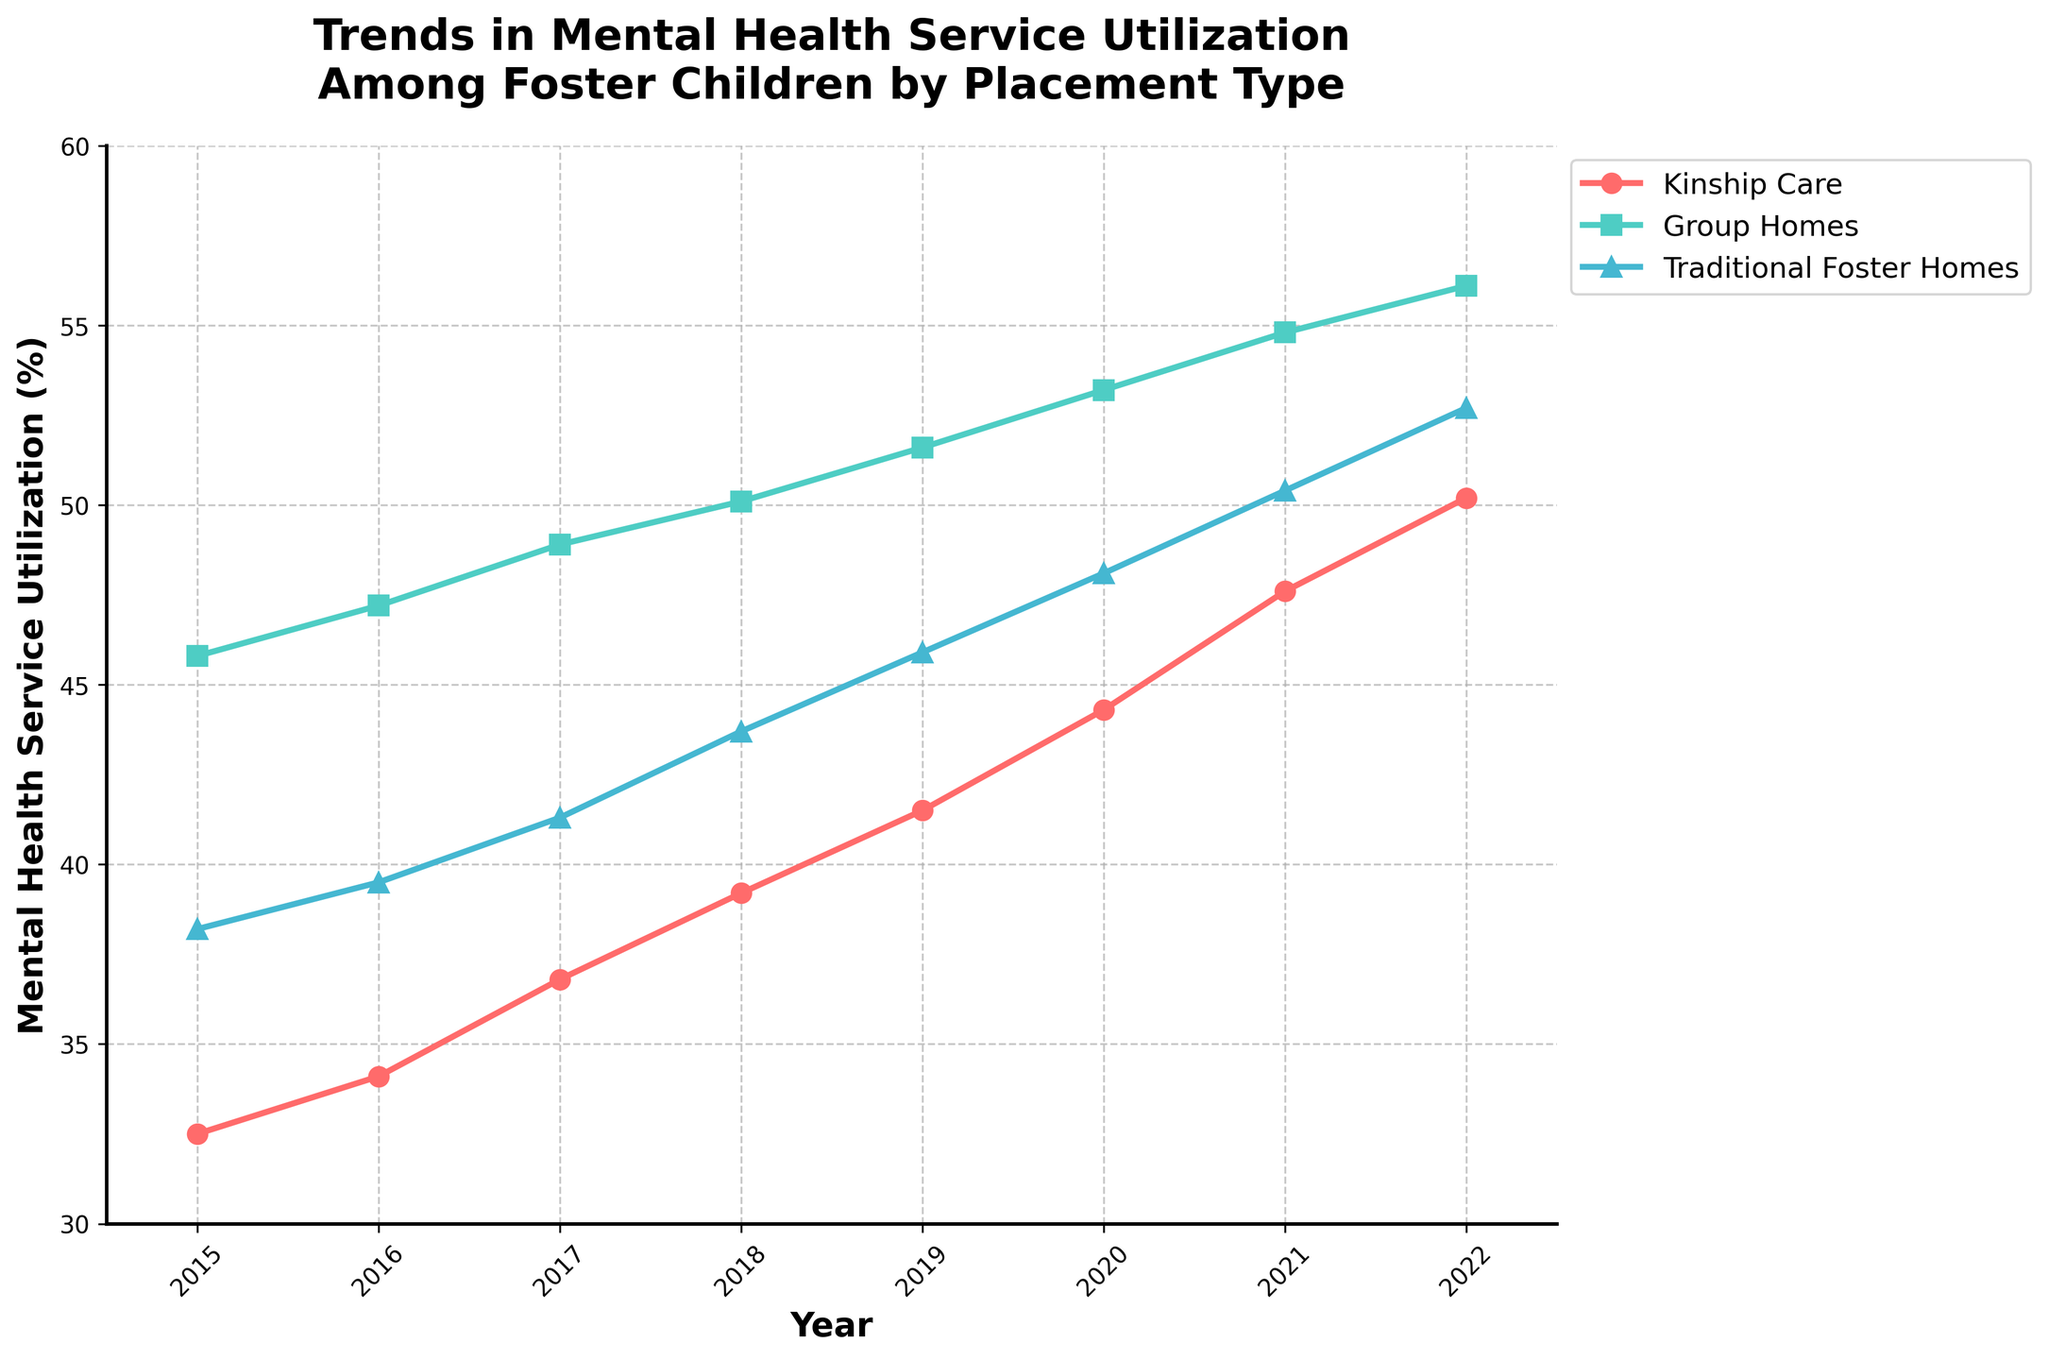What's the mental health service utilization trend for foster children in Traditional Foster Homes from 2015 to 2022? Starting from 38.2% in 2015, Traditional Foster Homes showed a steady increase each year, reaching 52.7% in 2022. By visually tracking the line representing Traditional Foster Homes (marked with triangles) and reading the values off the y-axis for each year, this trend is evident.
Answer: Increasing Which placement type had the highest utilization of mental health services in 2019? By comparing the plotted lines for the three placement types in 2019, the Group Homes line (green) is the highest on the y-axis at 51.6%.
Answer: Group Homes Between 2018 and 2019, which placement type saw the most significant increase in mental health service utilization? Subtract mental health service utilization in 2018 from 2019 for each placement type. Kinship Care: 41.5 - 39.2 = 2.3%, Group Homes: 51.6 - 50.1 = 1.5%, Traditional Foster Homes: 45.9 - 43.7 = 2.2%. The largest increase is for Kinship Care with a 2.3% increase.
Answer: Kinship Care Which placement type showed the smallest overall increase in mental health service utilization from 2015 to 2022? Calculate the difference between 2015 and 2022 for each placement type. Kinship Care: 50.2 - 32.5 = 17.7%, Group Homes: 56.1 - 45.8 = 10.3%, Traditional Foster Homes: 52.7 - 38.2 = 14.5%. Group Homes had the smallest increase with 10.3%.
Answer: Group Homes How did the utilization rates for the three placement types compare in 2020? In 2020, Kinship Care: 44.3%, Group Homes: 53.2%, Traditional Foster Homes: 48.1%. Group Homes had the highest rate, followed by Traditional Foster Homes, and then Kinship Care.
Answer: Group Homes > Traditional Foster Homes > Kinship Care Which year showed the highest mental health service utilization for Kinship Care? Refer directly to the plotted line for Kinship Care (red) and its endpoint. The highest point is in 2022 at 50.2%.
Answer: 2022 What is the average mental health service utilization for Group Homes over the years 2015-2022? Sum the utilization values for Group Homes for each year (45.8 + 47.2 + 48.9 + 50.1 + 51.6 + 53.2 + 54.8 + 56.1) = 407.7. Divide this by the number of years (8). The average is 407.7 / 8 = 50.96%.
Answer: 50.96% Compare the mental health service utilization between Kinship Care and Traditional Foster Homes in 2021. Which had a higher rate, and by how much? In 2021, Kinship Care: 47.6%, Traditional Foster Homes: 50.4%. Traditional Foster Homes had a higher rate by 50.4% - 47.6% = 2.8%.
Answer: Traditional Foster Homes by 2.8% How does the trend in mental health service utilization for Group Homes compare with that of Kinship Care from 2015 to 2022? Both lines show an increasing trend, but Group Homes starts higher and remains higher than Kinship Care throughout. Group Homes increases from 45.8% to 56.1%, while Kinship Care increases from 32.5% to 50.2%.
Answer: Both increasing, Group Homes consistently higher Calculate the cumulative increase in utilization for Traditional Foster Homes from 2015 to 2022. Subtract the percentage in 2015 from the percentage in 2022 for Traditional Foster Homes. The increase is 52.7% - 38.2% = 14.5%.
Answer: 14.5% 